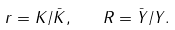Convert formula to latex. <formula><loc_0><loc_0><loc_500><loc_500>r = K / \bar { K } , \quad R = \bar { Y } / Y .</formula> 